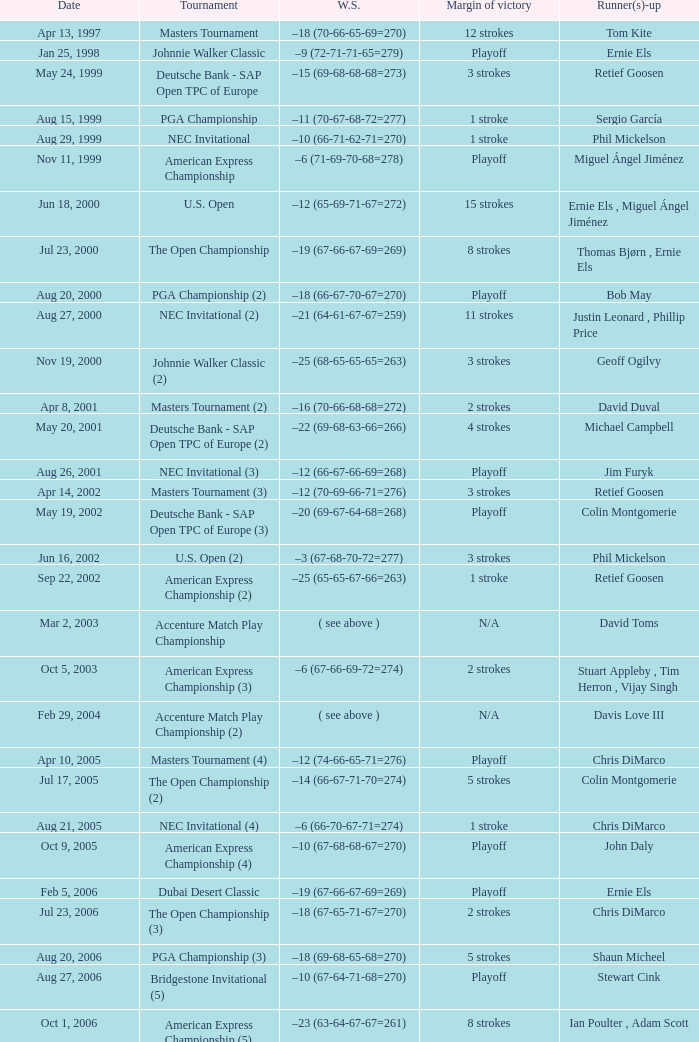Who is Runner(s)-up that has a Date of may 24, 1999? Retief Goosen. 